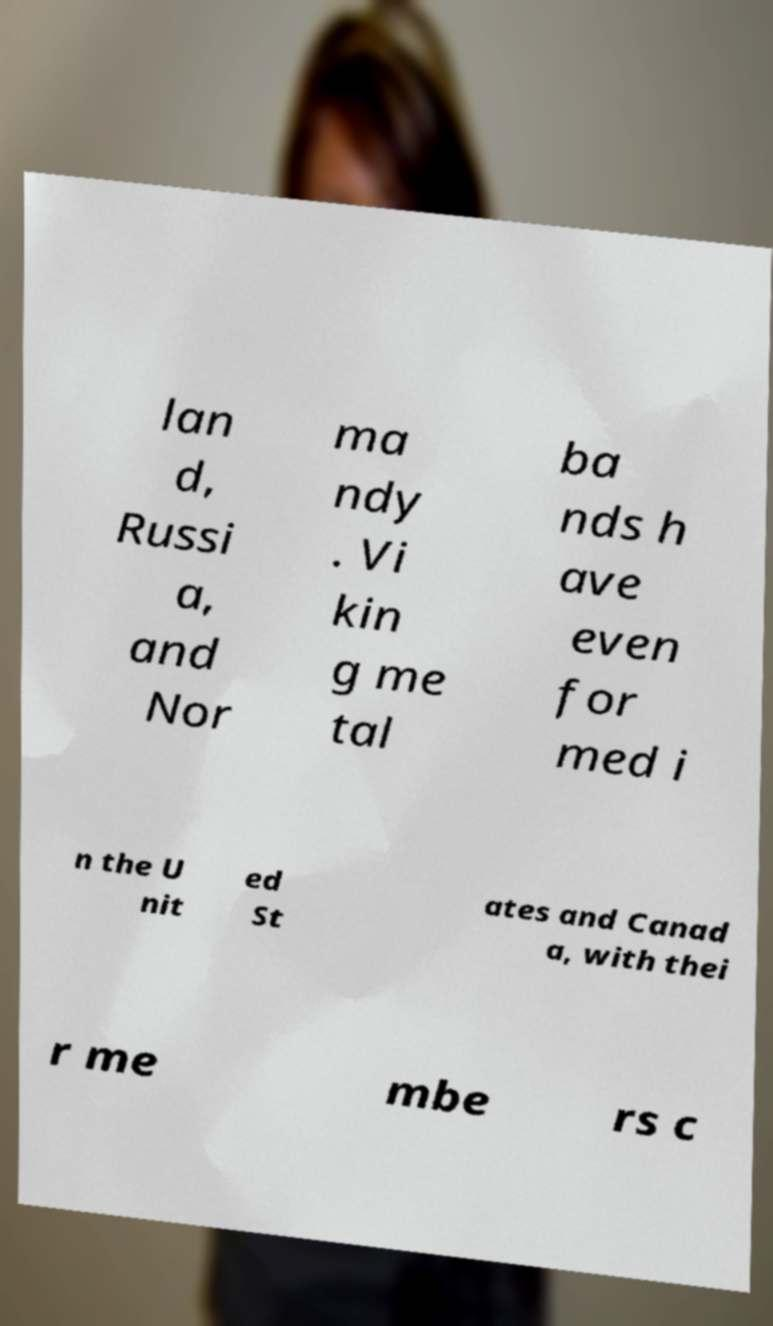I need the written content from this picture converted into text. Can you do that? lan d, Russi a, and Nor ma ndy . Vi kin g me tal ba nds h ave even for med i n the U nit ed St ates and Canad a, with thei r me mbe rs c 